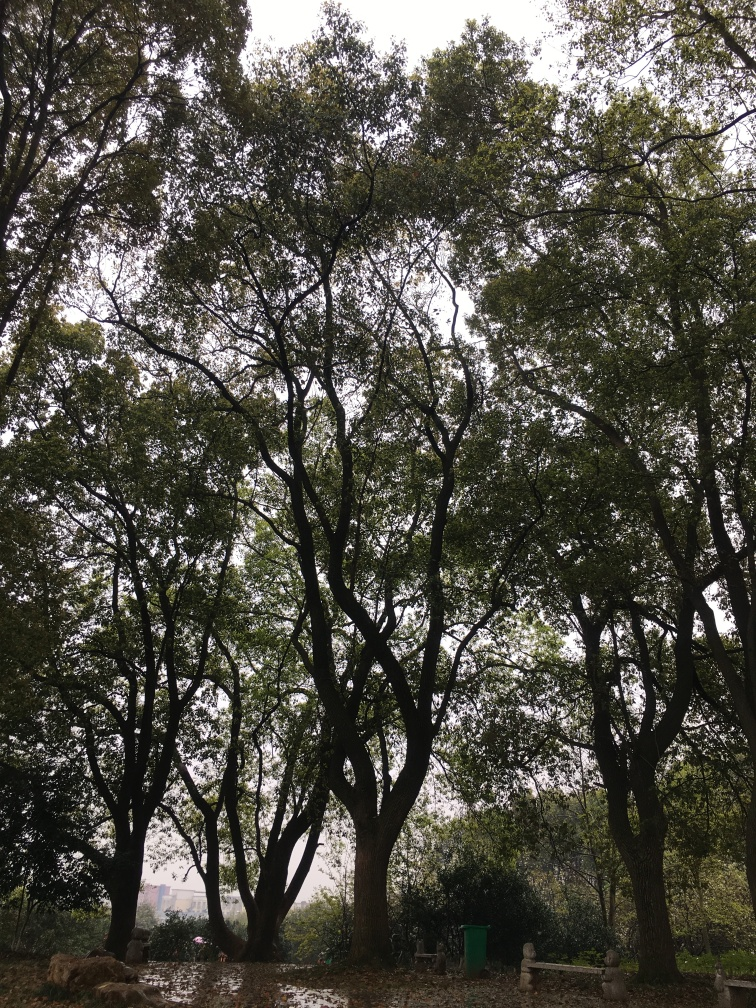What is the clarity of this image?
 high 